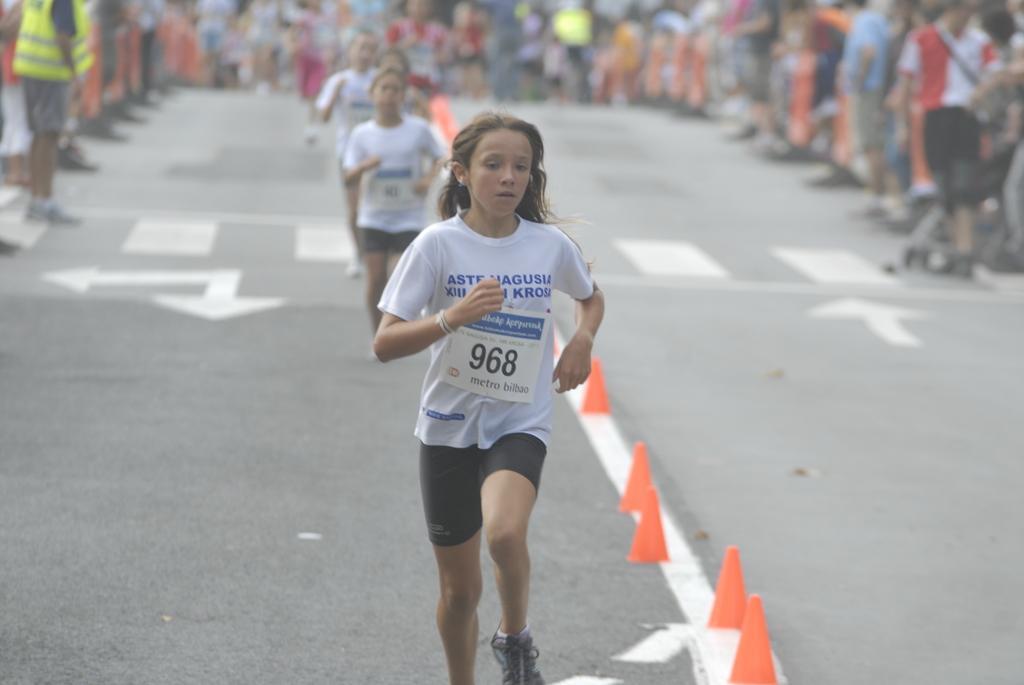Could you give a brief overview of what you see in this image? In the middle of this image, there are children in different color dresses, running on the road, on which there are white color lines. On both sides of this road, there are persons standing. 